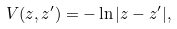<formula> <loc_0><loc_0><loc_500><loc_500>V ( z , z ^ { \prime } ) = - \ln | z - z ^ { \prime } | ,</formula> 